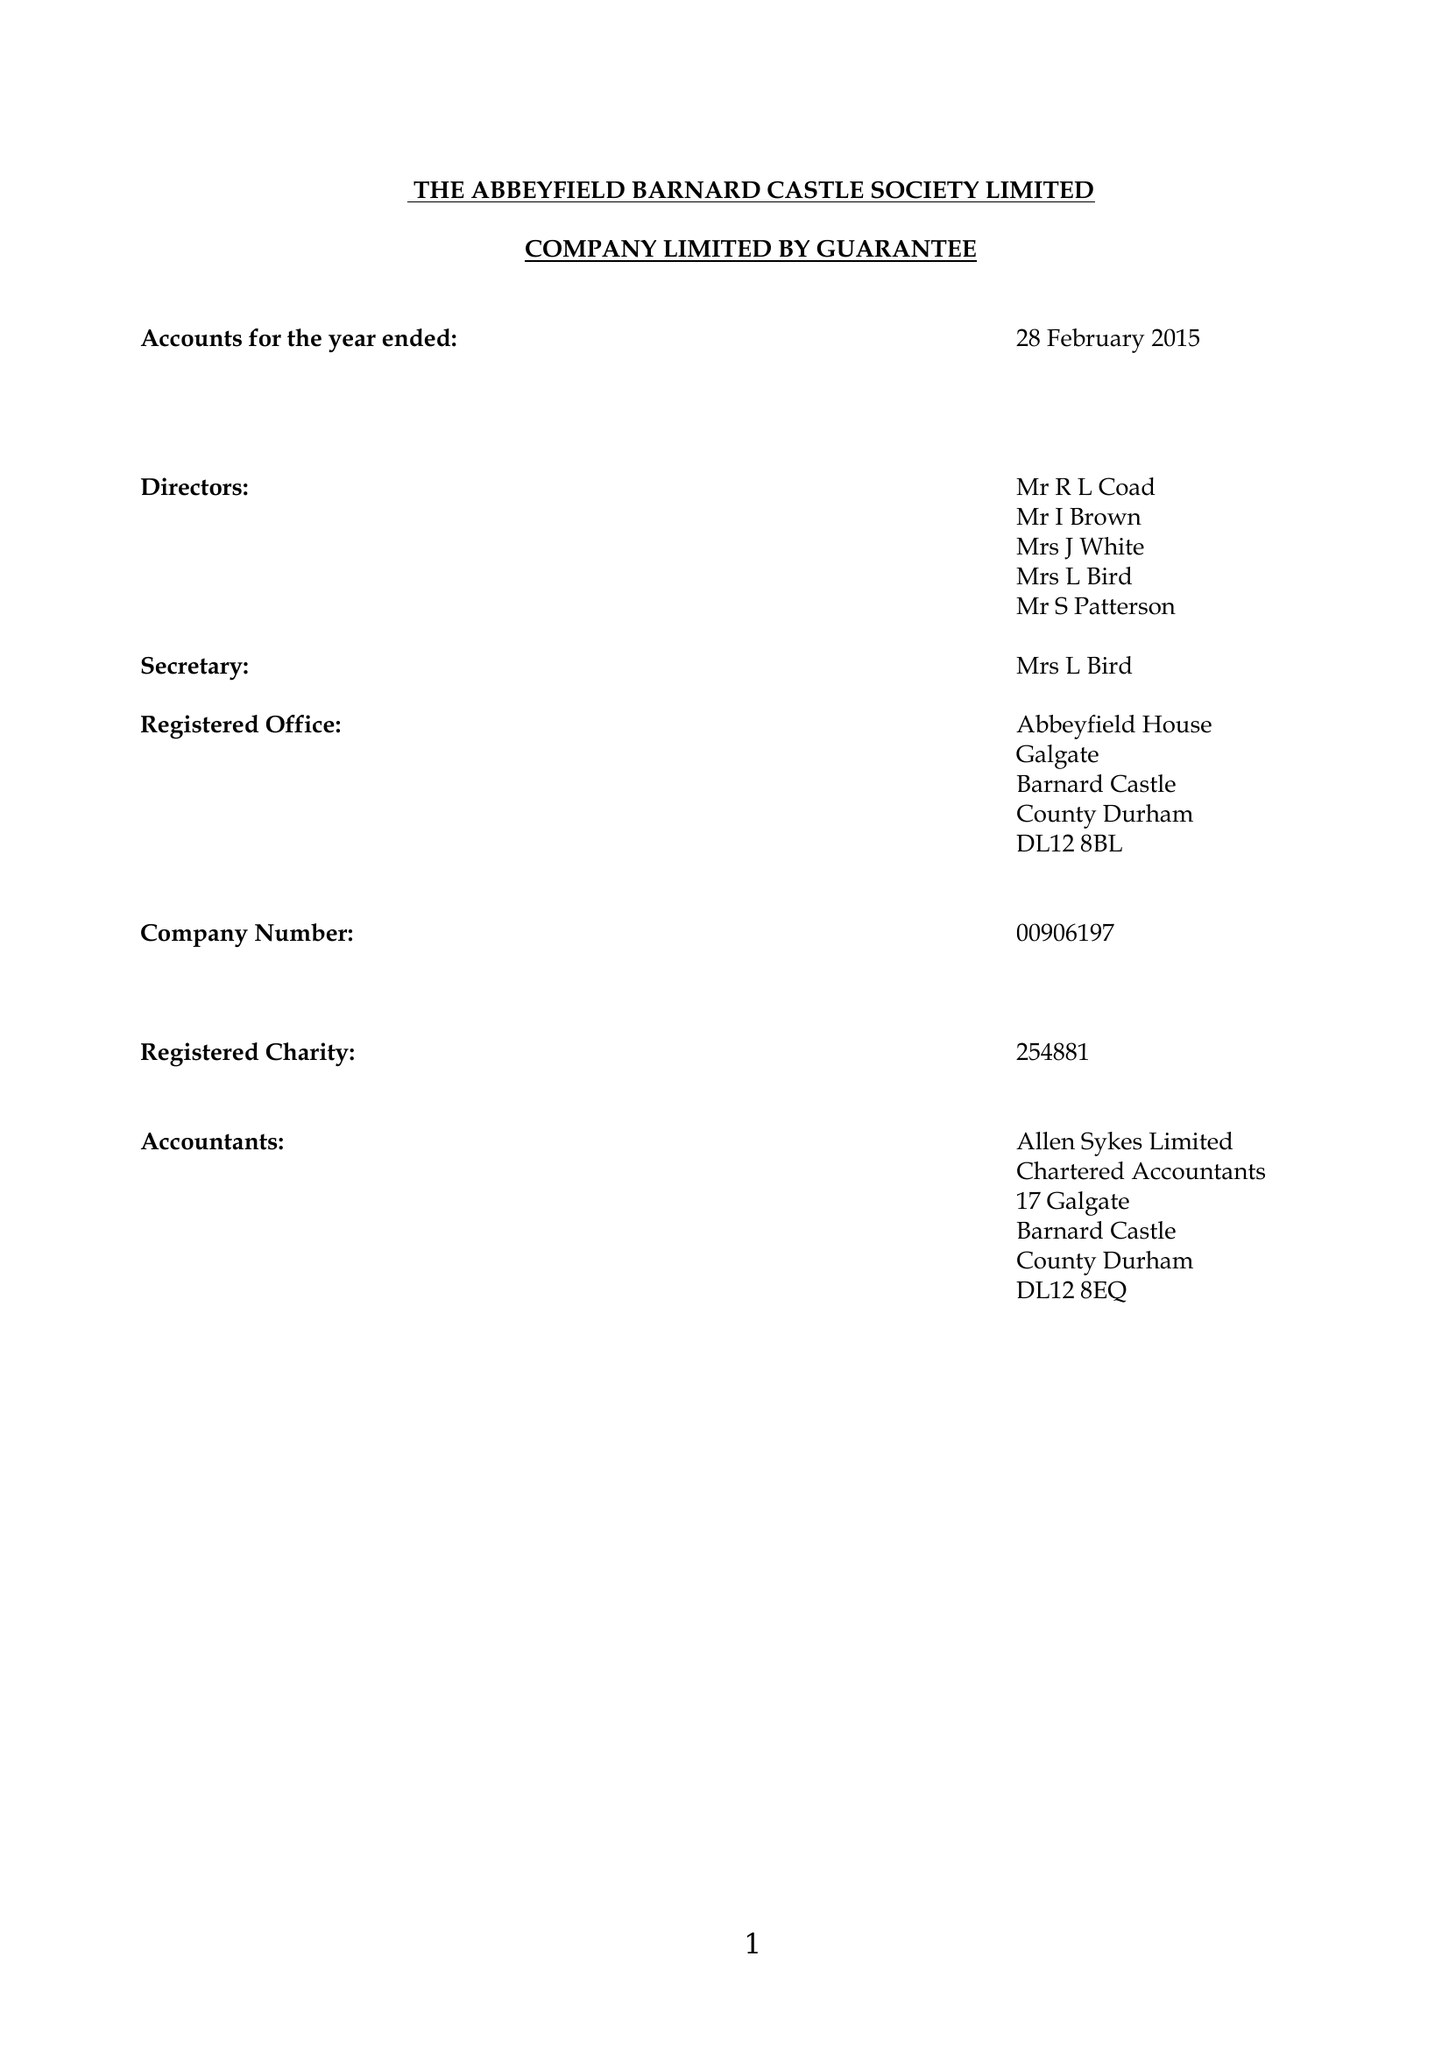What is the value for the address__post_town?
Answer the question using a single word or phrase. BARNARD CASTLE 